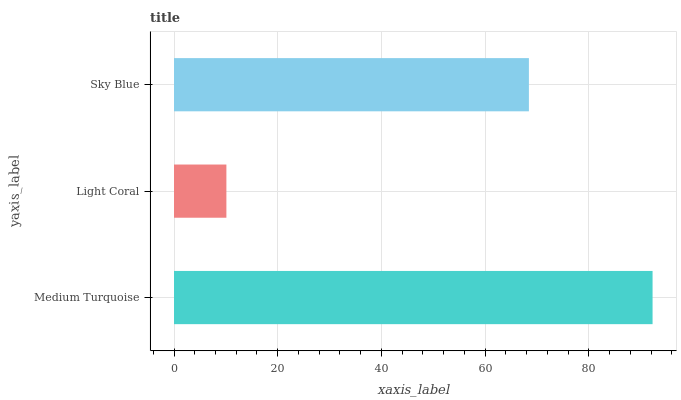Is Light Coral the minimum?
Answer yes or no. Yes. Is Medium Turquoise the maximum?
Answer yes or no. Yes. Is Sky Blue the minimum?
Answer yes or no. No. Is Sky Blue the maximum?
Answer yes or no. No. Is Sky Blue greater than Light Coral?
Answer yes or no. Yes. Is Light Coral less than Sky Blue?
Answer yes or no. Yes. Is Light Coral greater than Sky Blue?
Answer yes or no. No. Is Sky Blue less than Light Coral?
Answer yes or no. No. Is Sky Blue the high median?
Answer yes or no. Yes. Is Sky Blue the low median?
Answer yes or no. Yes. Is Medium Turquoise the high median?
Answer yes or no. No. Is Light Coral the low median?
Answer yes or no. No. 